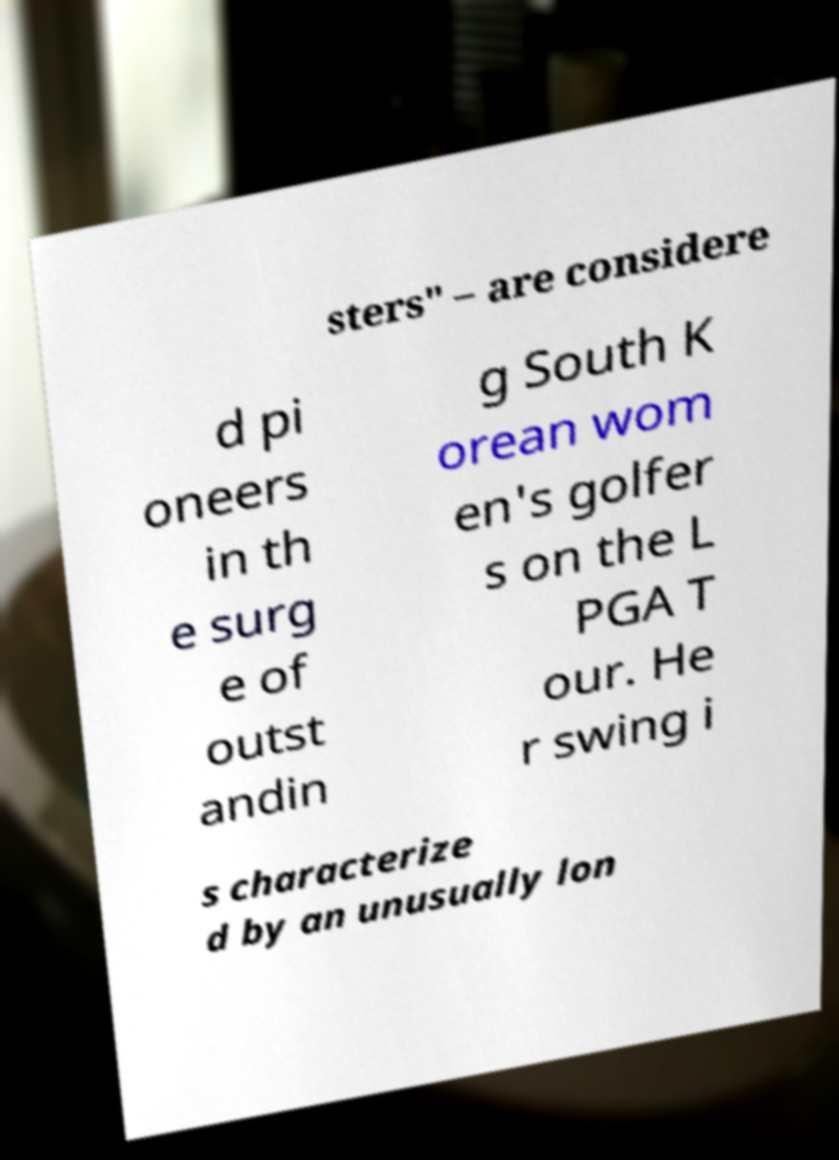Could you assist in decoding the text presented in this image and type it out clearly? sters" – are considere d pi oneers in th e surg e of outst andin g South K orean wom en's golfer s on the L PGA T our. He r swing i s characterize d by an unusually lon 